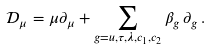<formula> <loc_0><loc_0><loc_500><loc_500>\mathcal { D } _ { \mu } = \mu \partial _ { \mu } + \sum _ { g = u , \tau , \lambda , c _ { 1 } , c _ { 2 } } \beta _ { g } \, \partial _ { g } \, .</formula> 